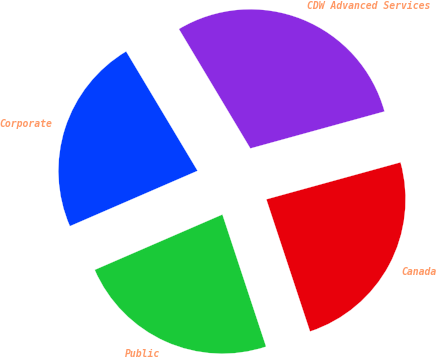<chart> <loc_0><loc_0><loc_500><loc_500><pie_chart><fcel>Corporate<fcel>Public<fcel>Canada<fcel>CDW Advanced Services<nl><fcel>22.93%<fcel>23.57%<fcel>24.2%<fcel>29.3%<nl></chart> 